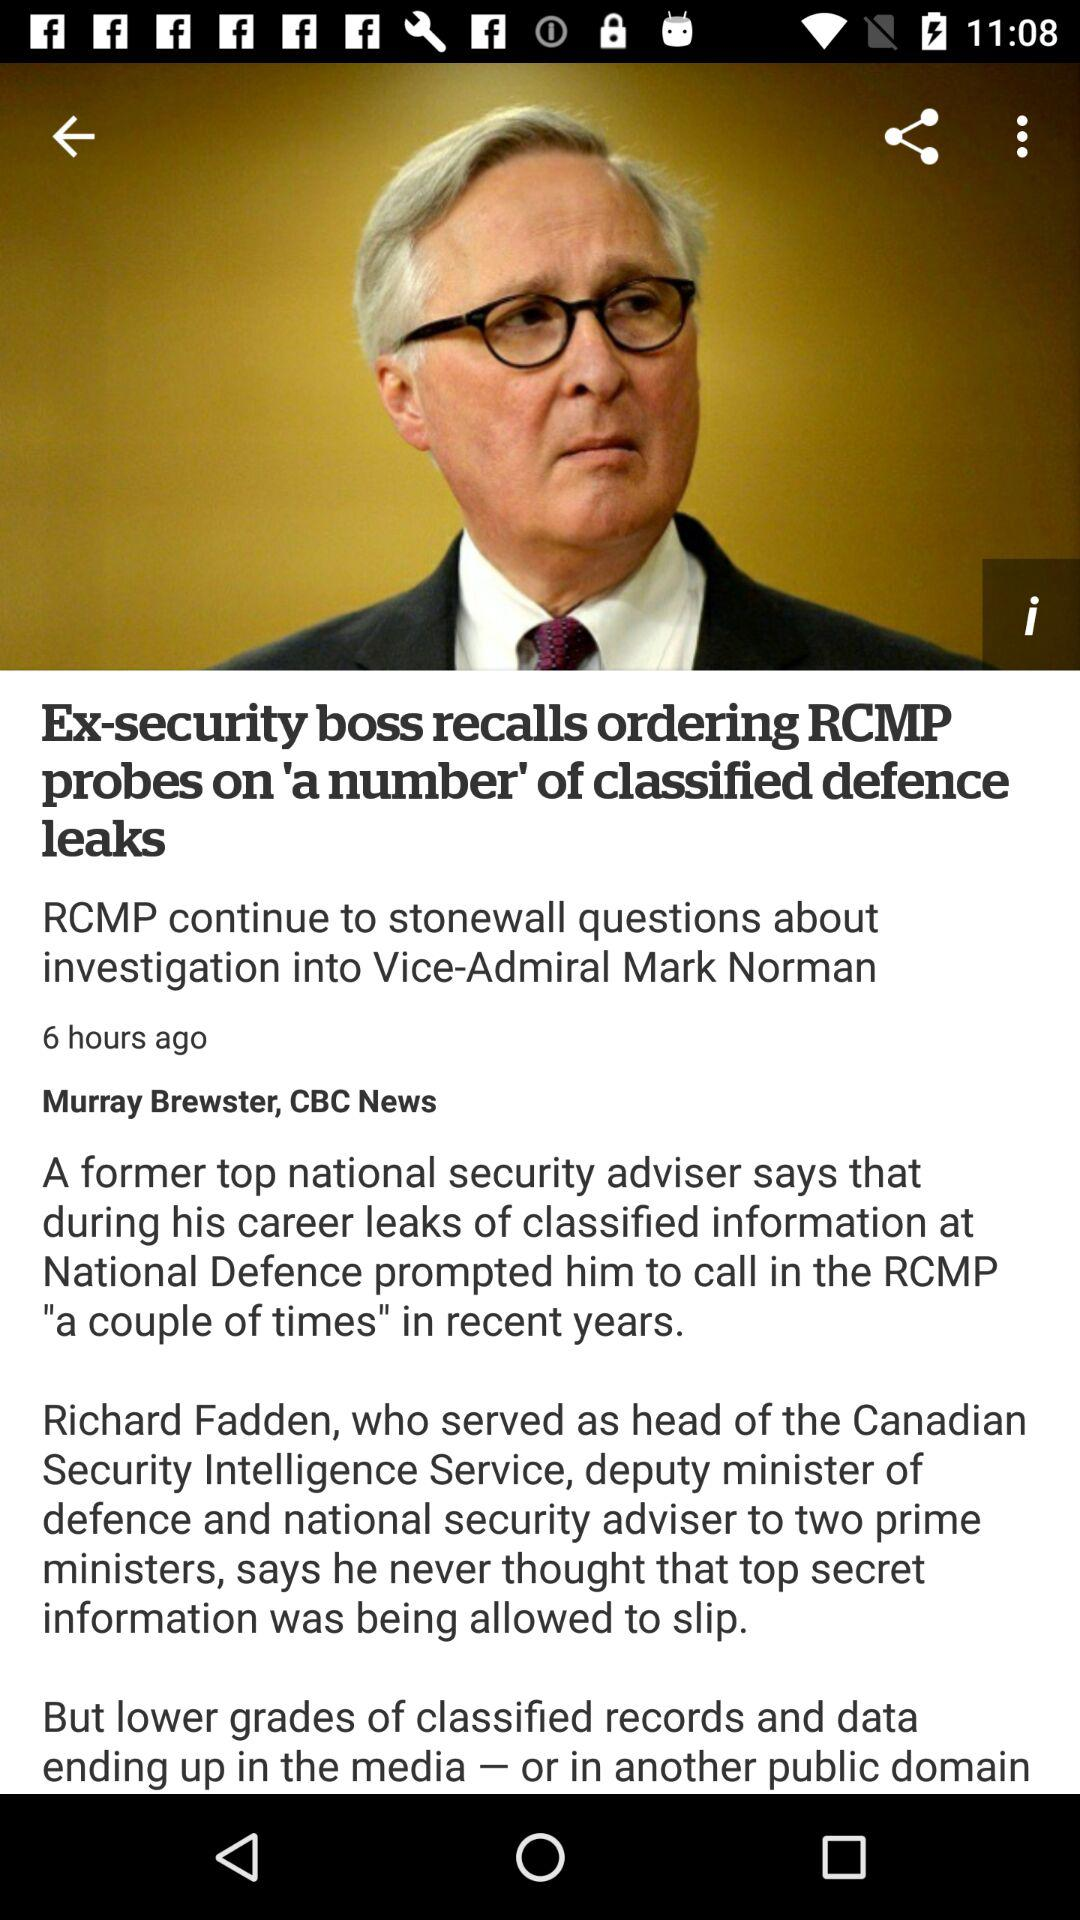When was the article published? The article was published 6 hours ago. 